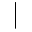<formula> <loc_0><loc_0><loc_500><loc_500>|</formula> 